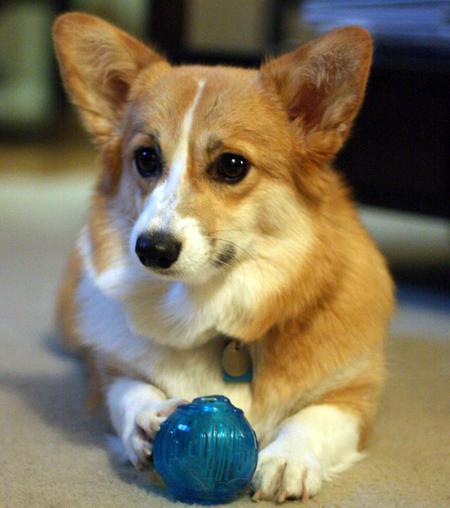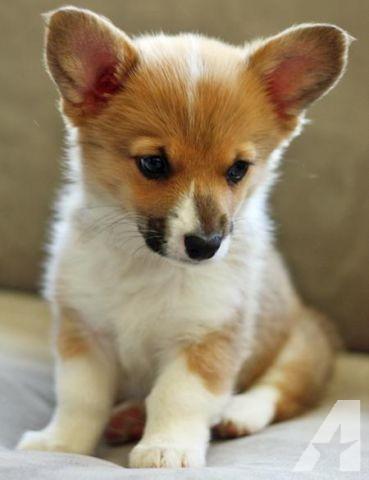The first image is the image on the left, the second image is the image on the right. Assess this claim about the two images: "An image shows an open-mouthed corgi dog that does not have its tongue hanging to one side.". Correct or not? Answer yes or no. No. The first image is the image on the left, the second image is the image on the right. Assess this claim about the two images: "the tongue is out on the dogs wide open mouth". Correct or not? Answer yes or no. No. 